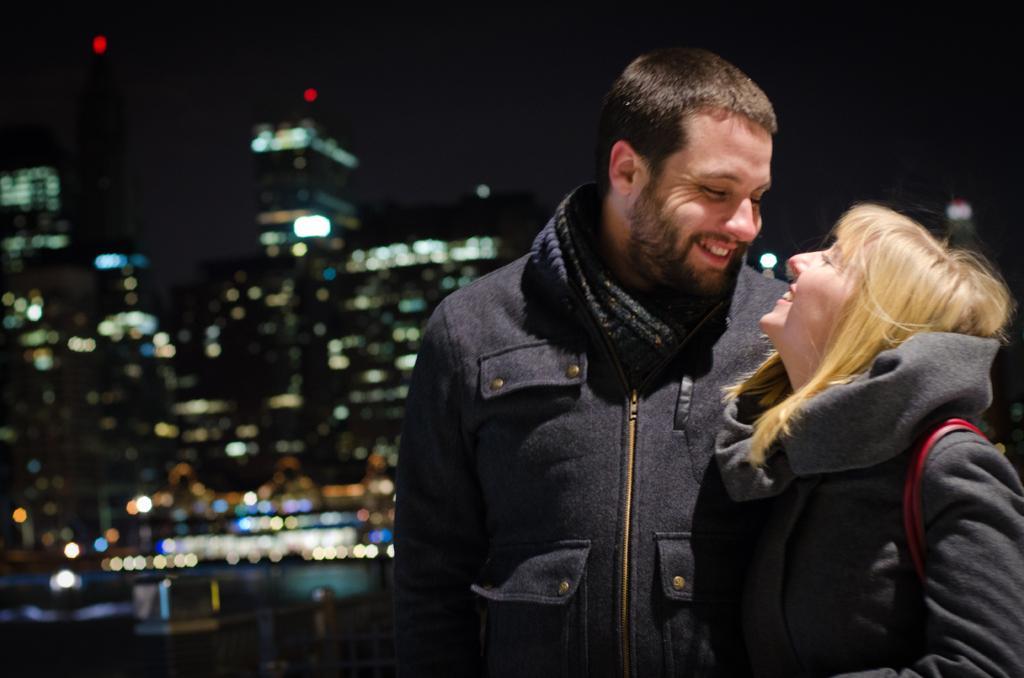How would you summarize this image in a sentence or two? On the left side there are big buildings. On the right side a man is standing and smiling, he wore a coat. Beside him a woman is looking at him. 